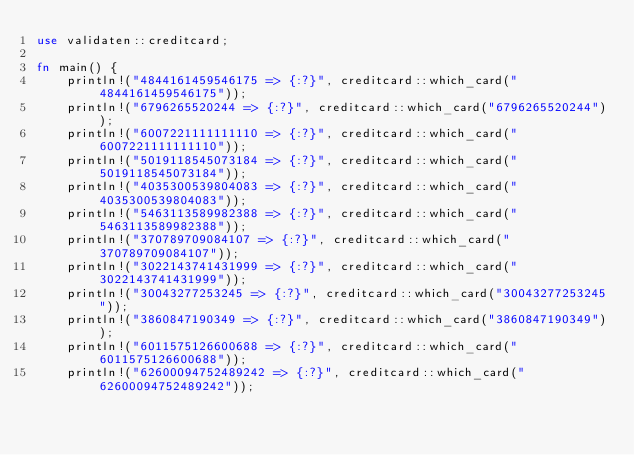Convert code to text. <code><loc_0><loc_0><loc_500><loc_500><_Rust_>use validaten::creditcard;

fn main() {
    println!("4844161459546175 => {:?}", creditcard::which_card("4844161459546175"));
    println!("6796265520244 => {:?}", creditcard::which_card("6796265520244"));
    println!("6007221111111110 => {:?}", creditcard::which_card("6007221111111110"));
    println!("5019118545073184 => {:?}", creditcard::which_card("5019118545073184"));
    println!("4035300539804083 => {:?}", creditcard::which_card("4035300539804083"));
    println!("5463113589982388 => {:?}", creditcard::which_card("5463113589982388"));
    println!("370789709084107 => {:?}", creditcard::which_card("370789709084107"));
    println!("3022143741431999 => {:?}", creditcard::which_card("3022143741431999"));
    println!("30043277253245 => {:?}", creditcard::which_card("30043277253245"));
    println!("3860847190349 => {:?}", creditcard::which_card("3860847190349"));
    println!("6011575126600688 => {:?}", creditcard::which_card("6011575126600688"));
    println!("62600094752489242 => {:?}", creditcard::which_card("62600094752489242"));</code> 